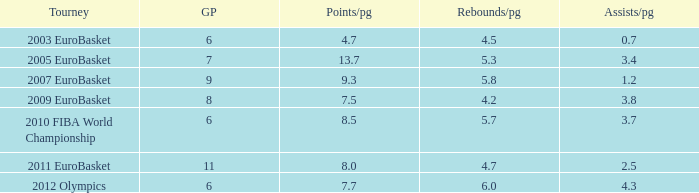How many games played have 4.7 as points per game? 6.0. Could you parse the entire table as a dict? {'header': ['Tourney', 'GP', 'Points/pg', 'Rebounds/pg', 'Assists/pg'], 'rows': [['2003 EuroBasket', '6', '4.7', '4.5', '0.7'], ['2005 EuroBasket', '7', '13.7', '5.3', '3.4'], ['2007 EuroBasket', '9', '9.3', '5.8', '1.2'], ['2009 EuroBasket', '8', '7.5', '4.2', '3.8'], ['2010 FIBA World Championship', '6', '8.5', '5.7', '3.7'], ['2011 EuroBasket', '11', '8.0', '4.7', '2.5'], ['2012 Olympics', '6', '7.7', '6.0', '4.3']]} 